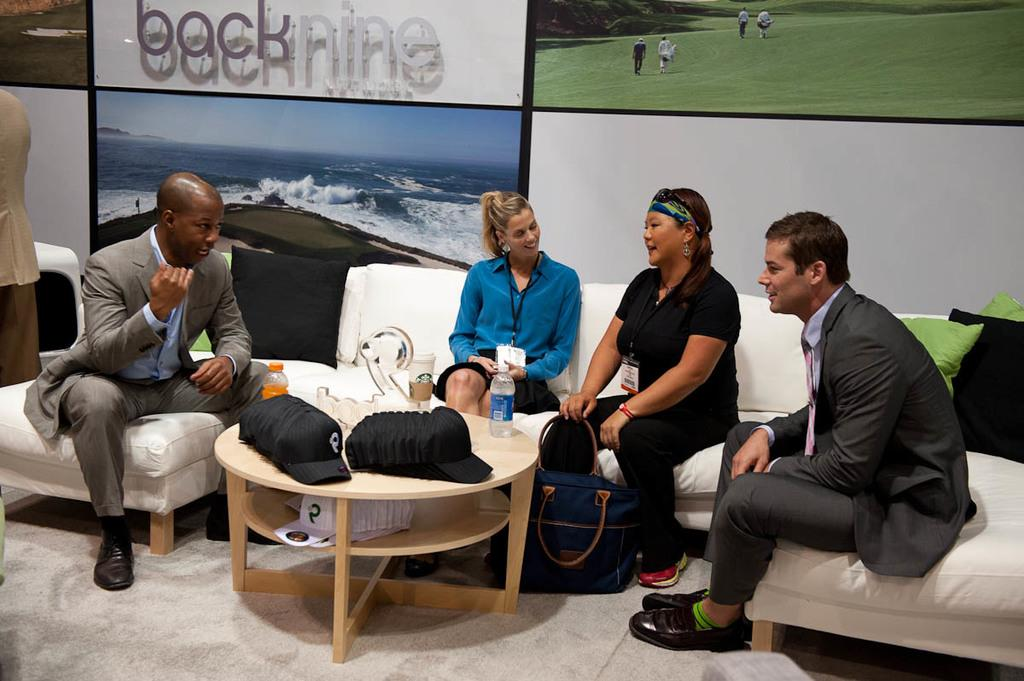How many people are in the image? There is a group of people in the image. What are the people doing in the image? The people are sitting on a couch. What is in front of the couch? There is a table in front of the couch. What can be seen on the table? There is a bottle on the table, along with other objects. Can you describe the pig that is sitting next to the people on the couch? There is no pig present in the image; only a group of people sitting on a couch can be seen. 